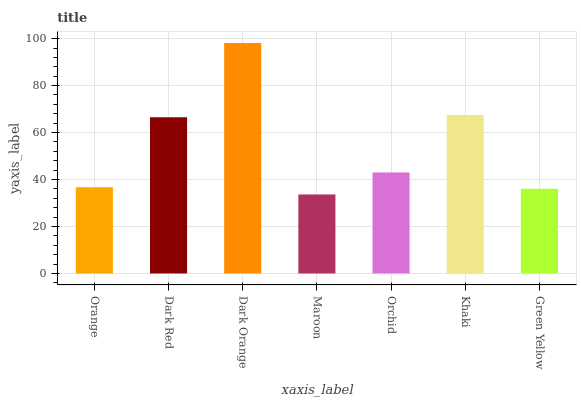Is Maroon the minimum?
Answer yes or no. Yes. Is Dark Orange the maximum?
Answer yes or no. Yes. Is Dark Red the minimum?
Answer yes or no. No. Is Dark Red the maximum?
Answer yes or no. No. Is Dark Red greater than Orange?
Answer yes or no. Yes. Is Orange less than Dark Red?
Answer yes or no. Yes. Is Orange greater than Dark Red?
Answer yes or no. No. Is Dark Red less than Orange?
Answer yes or no. No. Is Orchid the high median?
Answer yes or no. Yes. Is Orchid the low median?
Answer yes or no. Yes. Is Orange the high median?
Answer yes or no. No. Is Green Yellow the low median?
Answer yes or no. No. 